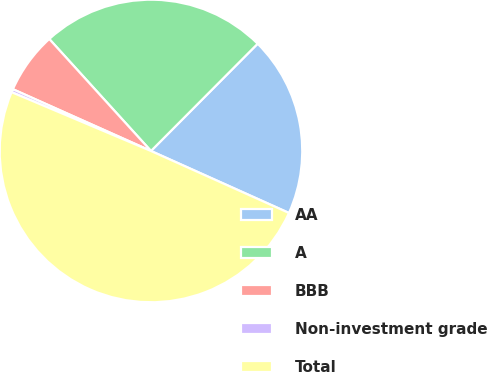<chart> <loc_0><loc_0><loc_500><loc_500><pie_chart><fcel>AA<fcel>A<fcel>BBB<fcel>Non-investment grade<fcel>Total<nl><fcel>19.26%<fcel>24.19%<fcel>6.57%<fcel>0.34%<fcel>49.63%<nl></chart> 